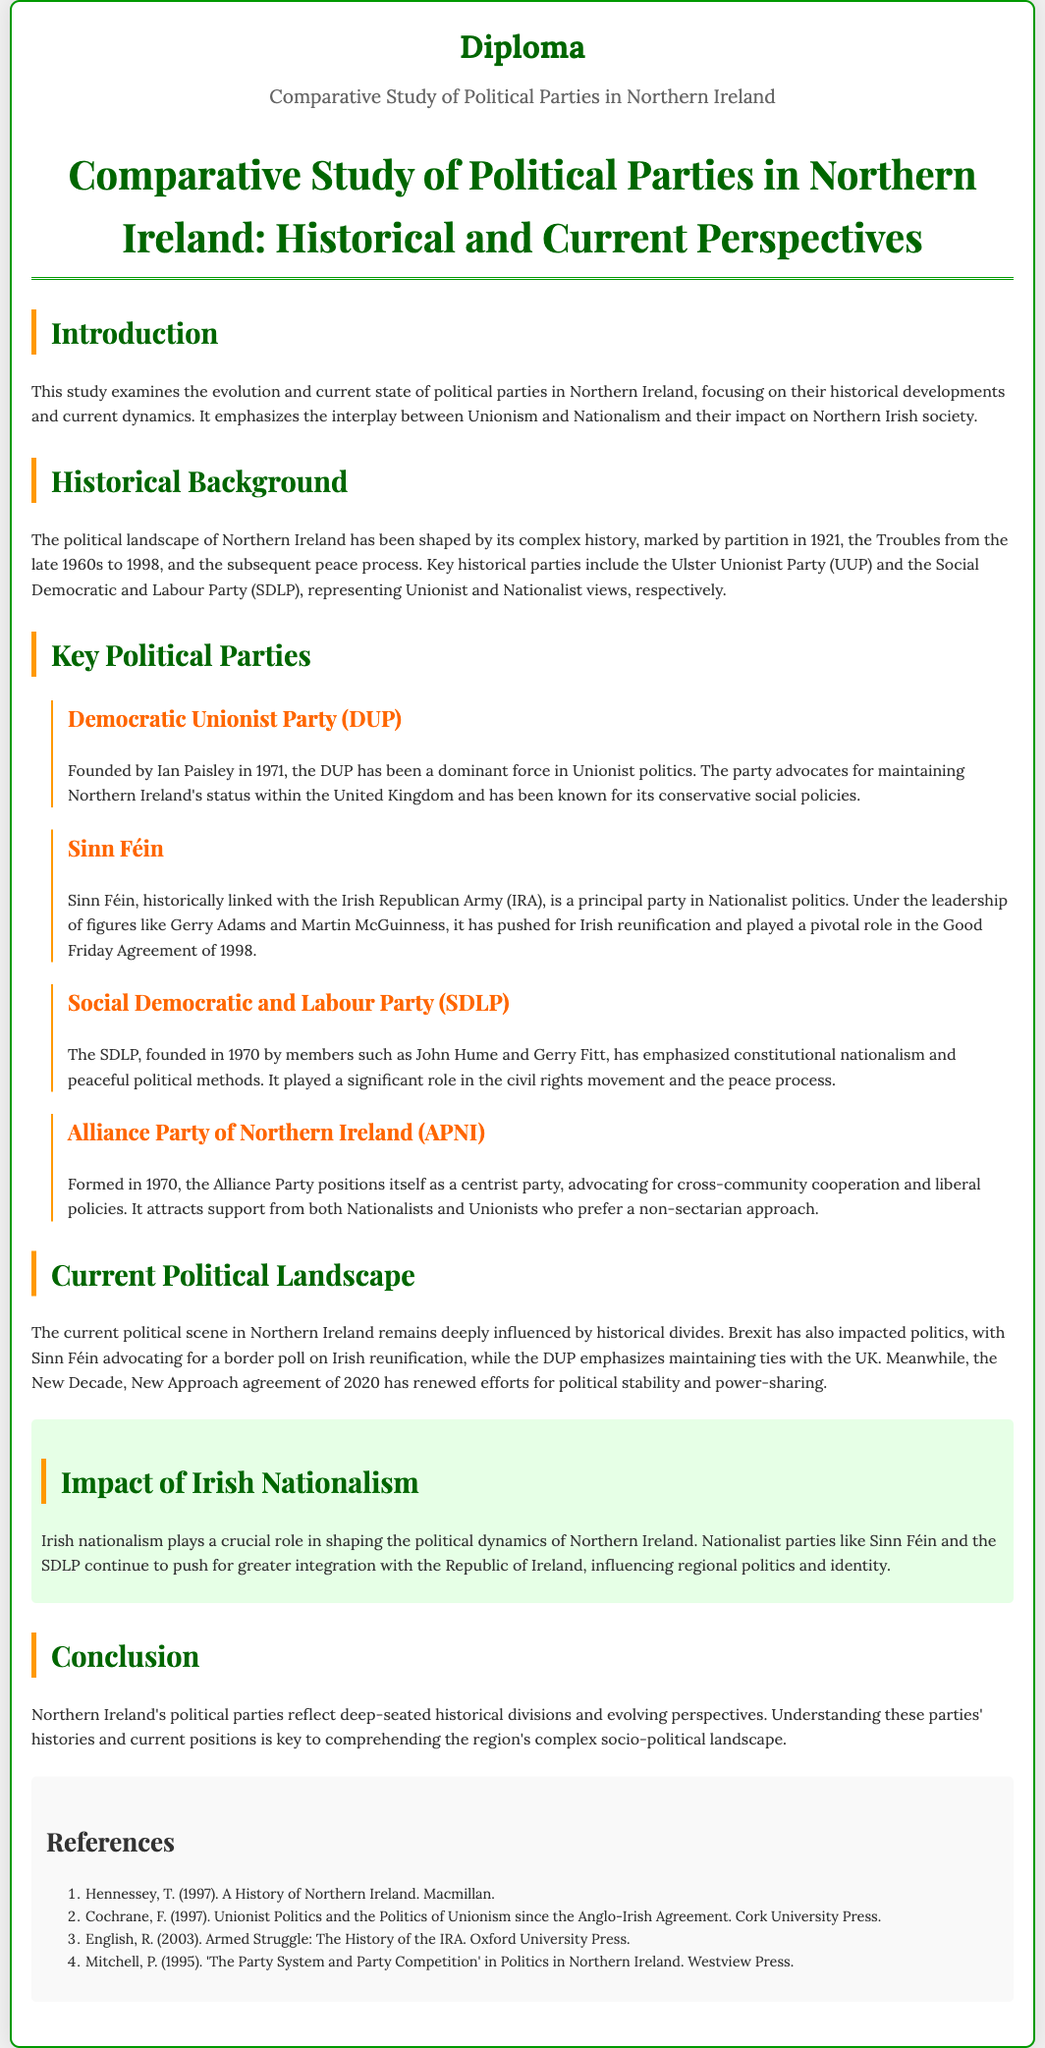What are the key historical political parties in Northern Ireland? The key historical parties include the Ulster Unionist Party (UUP) and the Social Democratic and Labour Party (SDLP), which represent Unionist and Nationalist views respectively.
Answer: UUP, SDLP Who founded the Democratic Unionist Party (DUP)? The DUP was founded by Ian Paisley in 1971.
Answer: Ian Paisley What is the principal aim of Sinn Féin? Sinn Féin pushes for Irish reunification and has played a pivotal role in the Good Friday Agreement of 1998.
Answer: Irish reunification When was the Good Friday Agreement established? The Good Friday Agreement was established in 1998, marking a significant milestone in the peace process.
Answer: 1998 What impact has Brexit had on Northern Irish politics according to the document? Brexit has impacted politics, leading to discussions on a border poll for Irish reunification advocated by Sinn Féin and maintaining UK ties emphasized by the DUP.
Answer: Brexit How does the Alliance Party of Northern Ireland position itself? The Alliance Party positions itself as a centrist party advocating for cross-community cooperation.
Answer: Centrist What does the section on "Impact of Irish Nationalism" highlight? The section highlights that Irish nationalism significantly shapes Northern Ireland's political dynamics and influences regional politics and identity.
Answer: Significant influence What historical event marked the partition of Northern Ireland? The partition of Northern Ireland occurred in 1921.
Answer: 1921 